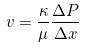Convert formula to latex. <formula><loc_0><loc_0><loc_500><loc_500>v = \frac { \kappa } { \mu } \frac { \Delta P } { \Delta x }</formula> 